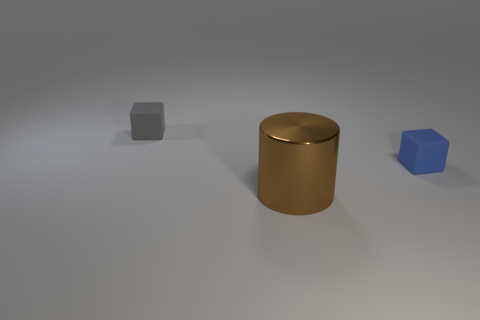Subtract 2 blocks. How many blocks are left? 0 Add 3 gray objects. How many objects exist? 6 Subtract all gray cubes. How many cubes are left? 1 Subtract all cylinders. How many objects are left? 2 Subtract 1 brown cylinders. How many objects are left? 2 Subtract all red cylinders. Subtract all purple blocks. How many cylinders are left? 1 Subtract all gray rubber cubes. Subtract all gray rubber blocks. How many objects are left? 1 Add 1 tiny gray rubber cubes. How many tiny gray rubber cubes are left? 2 Add 3 gray matte objects. How many gray matte objects exist? 4 